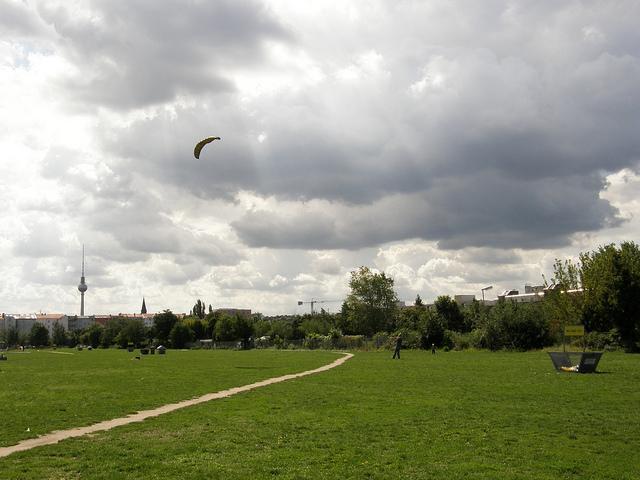How many chairs are under the wood board?
Give a very brief answer. 0. 